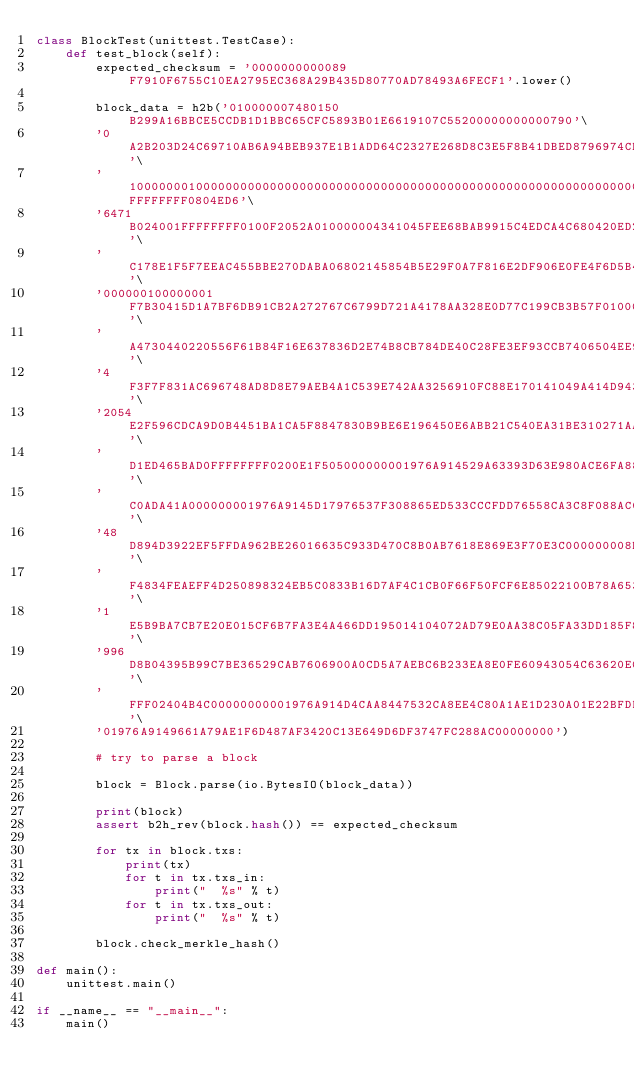Convert code to text. <code><loc_0><loc_0><loc_500><loc_500><_Python_>class BlockTest(unittest.TestCase):
    def test_block(self):
        expected_checksum = '0000000000089F7910F6755C10EA2795EC368A29B435D80770AD78493A6FECF1'.lower()

        block_data = h2b('010000007480150B299A16BBCE5CCDB1D1BBC65CFC5893B01E6619107C55200000000000790'\
        '0A2B203D24C69710AB6A94BEB937E1B1ADD64C2327E268D8C3E5F8B41DBED8796974CED66471B204C3247030'\
        '1000000010000000000000000000000000000000000000000000000000000000000000000FFFFFFFF0804ED6'\
        '6471B024001FFFFFFFF0100F2052A010000004341045FEE68BAB9915C4EDCA4C680420ED28BBC369ED84D48A'\
        'C178E1F5F7EEAC455BBE270DABA06802145854B5E29F0A7F816E2DF906E0FE4F6D5B4C9B92940E4F0EDAC000'\
        '000000100000001F7B30415D1A7BF6DB91CB2A272767C6799D721A4178AA328E0D77C199CB3B57F010000008'\
        'A4730440220556F61B84F16E637836D2E74B8CB784DE40C28FE3EF93CCB7406504EE9C7CAA5022043BD4749D'\
        '4F3F7F831AC696748AD8D8E79AEB4A1C539E742AA3256910FC88E170141049A414D94345712893A828DE57B4C'\
        '2054E2F596CDCA9D0B4451BA1CA5F8847830B9BE6E196450E6ABB21C540EA31BE310271AA00A49ED0BA930743'\
        'D1ED465BAD0FFFFFFFF0200E1F505000000001976A914529A63393D63E980ACE6FA885C5A89E4F27AA08988AC'\
        'C0ADA41A000000001976A9145D17976537F308865ED533CCCFDD76558CA3C8F088AC000000000100000001651'\
        '48D894D3922EF5FFDA962BE26016635C933D470C8B0AB7618E869E3F70E3C000000008B48304502207F5779EB'\
        'F4834FEAEFF4D250898324EB5C0833B16D7AF4C1CB0F66F50FCF6E85022100B78A65377FD018281E77285EFC3'\
        '1E5B9BA7CB7E20E015CF6B7FA3E4A466DD195014104072AD79E0AA38C05FA33DD185F84C17F611E58A8658CE'\
        '996D8B04395B99C7BE36529CAB7606900A0CD5A7AEBC6B233EA8E0FE60943054C63620E05E5B85F0426FFFFF'\
        'FFF02404B4C00000000001976A914D4CAA8447532CA8EE4C80A1AE1D230A01E22BFDB88AC8013A0DE0100000'\
        '01976A9149661A79AE1F6D487AF3420C13E649D6DF3747FC288AC00000000')

        # try to parse a block

        block = Block.parse(io.BytesIO(block_data))

        print(block)
        assert b2h_rev(block.hash()) == expected_checksum

        for tx in block.txs:
            print(tx)
            for t in tx.txs_in:
                print("  %s" % t)
            for t in tx.txs_out:
                print("  %s" % t)

        block.check_merkle_hash()

def main():
    unittest.main()

if __name__ == "__main__":
    main()
</code> 